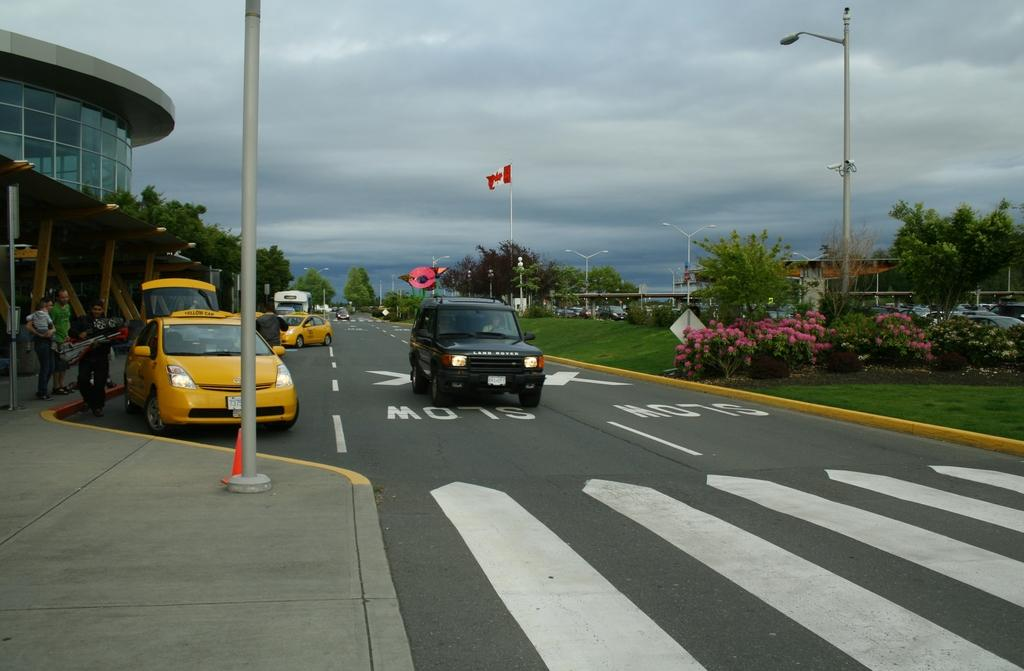<image>
Create a compact narrative representing the image presented. The road in front of a modern building has SLOW stenciled onto it. 